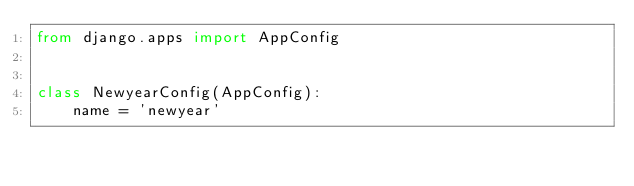<code> <loc_0><loc_0><loc_500><loc_500><_Python_>from django.apps import AppConfig


class NewyearConfig(AppConfig):
    name = 'newyear'
</code> 